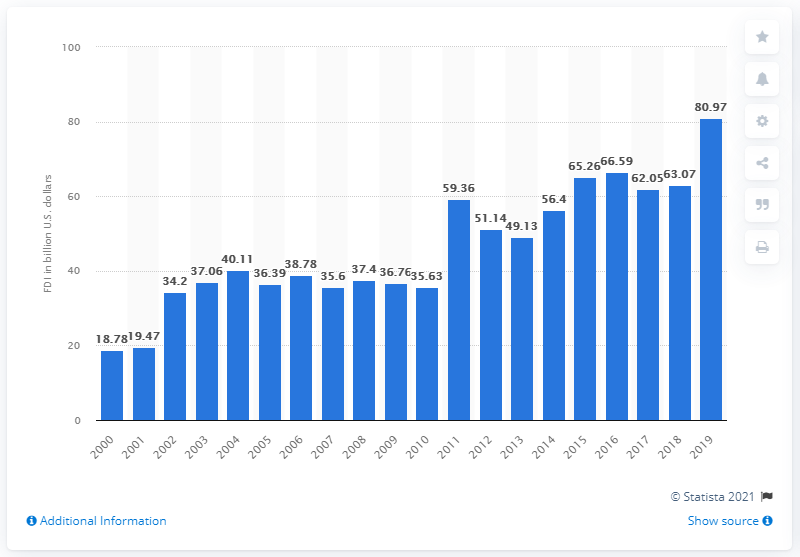Mention a couple of crucial points in this snapshot. In 2019, the amount of Australian foreign direct investments in the United States was 80.97. 